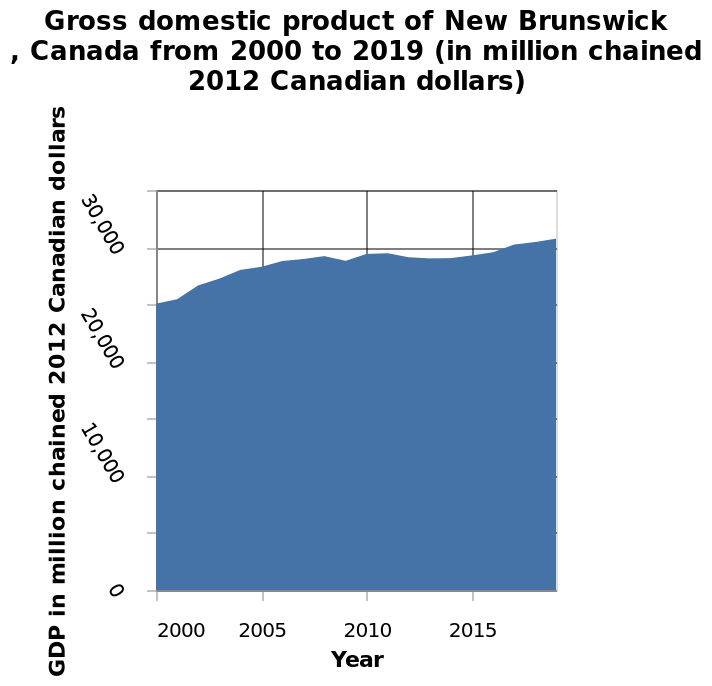<image>
please enumerates aspects of the construction of the chart Gross domestic product of New Brunswick , Canada from 2000 to 2019 (in million chained 2012 Canadian dollars) is a area chart. The x-axis shows Year along linear scale of range 2000 to 2015 while the y-axis measures GDP in million chained 2012 Canadian dollars on linear scale of range 0 to 35,000. Did the GDP continuously rise over the mentioned period? Yes, the GDP continued to rise apart from a drop in 2009 and a slump between 2011-2015. From which years did the GDP experience a slump?  The GDP experienced a slump between 2011 and 2015. What is the range of the x-axis on the chart? The x-axis has a range from 2000 to 2015. 